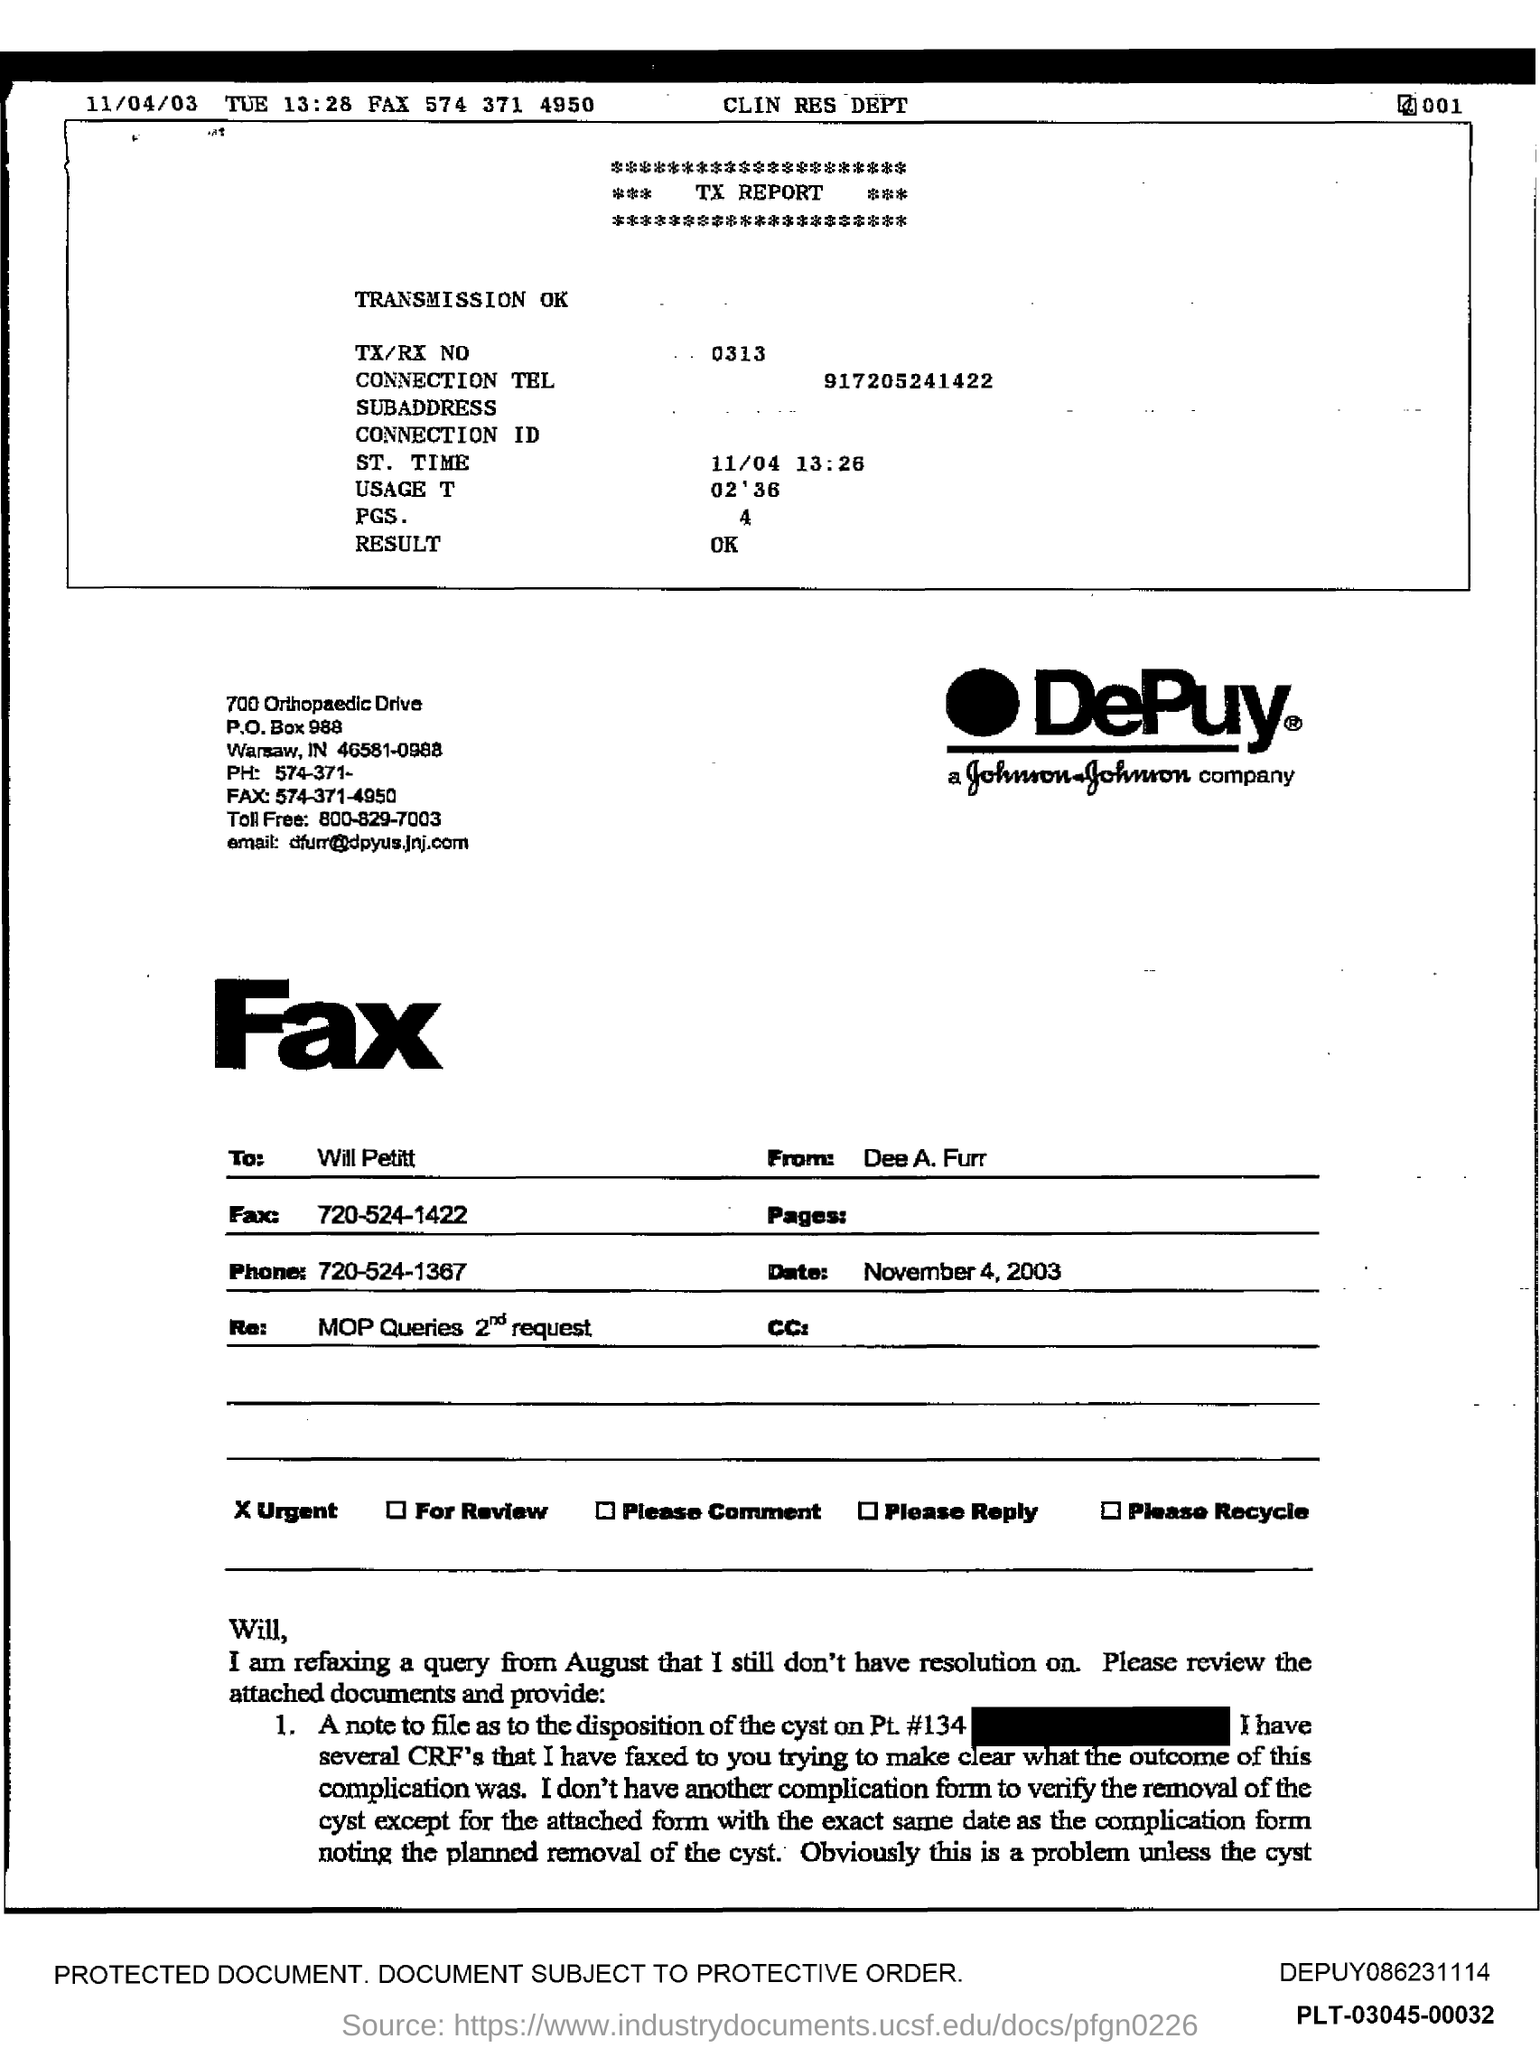Who is the recipient of this fax and what is the date it was sent? The fax is addressed to an individual named Will Pettit and it is dated November 4, 2003. It seems like there's some confusion mentioned in the message; what's the issue? The sender is seeking clarification on a previous communication regarding the removal of a cyst, noting a possible discrepancy or oversight in the documentation provided. 